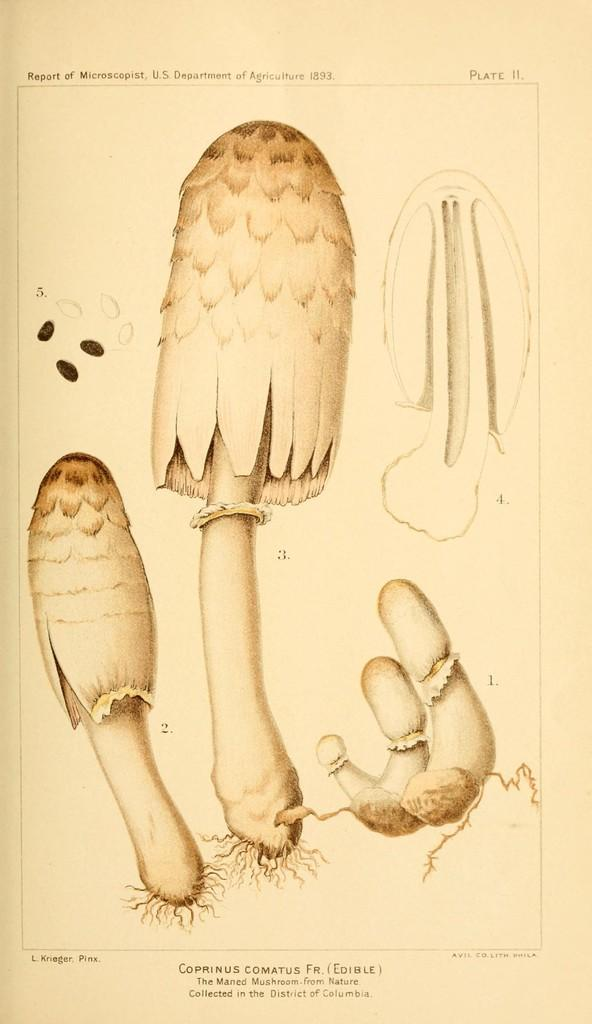What is the main subject of the image? The main subject of the image is a paper. What is depicted in the center of the paper? There are mushrooms in the center of the image. Where can text be found on the paper? There is text at the top and bottom of the image. How many light bulbs are visible in the image? There are no light bulbs present in the image; it features a paper with mushrooms and text. What type of animals can be seen at the zoo in the image? There is no zoo or animals present in the image; it features a paper with mushrooms and text. 